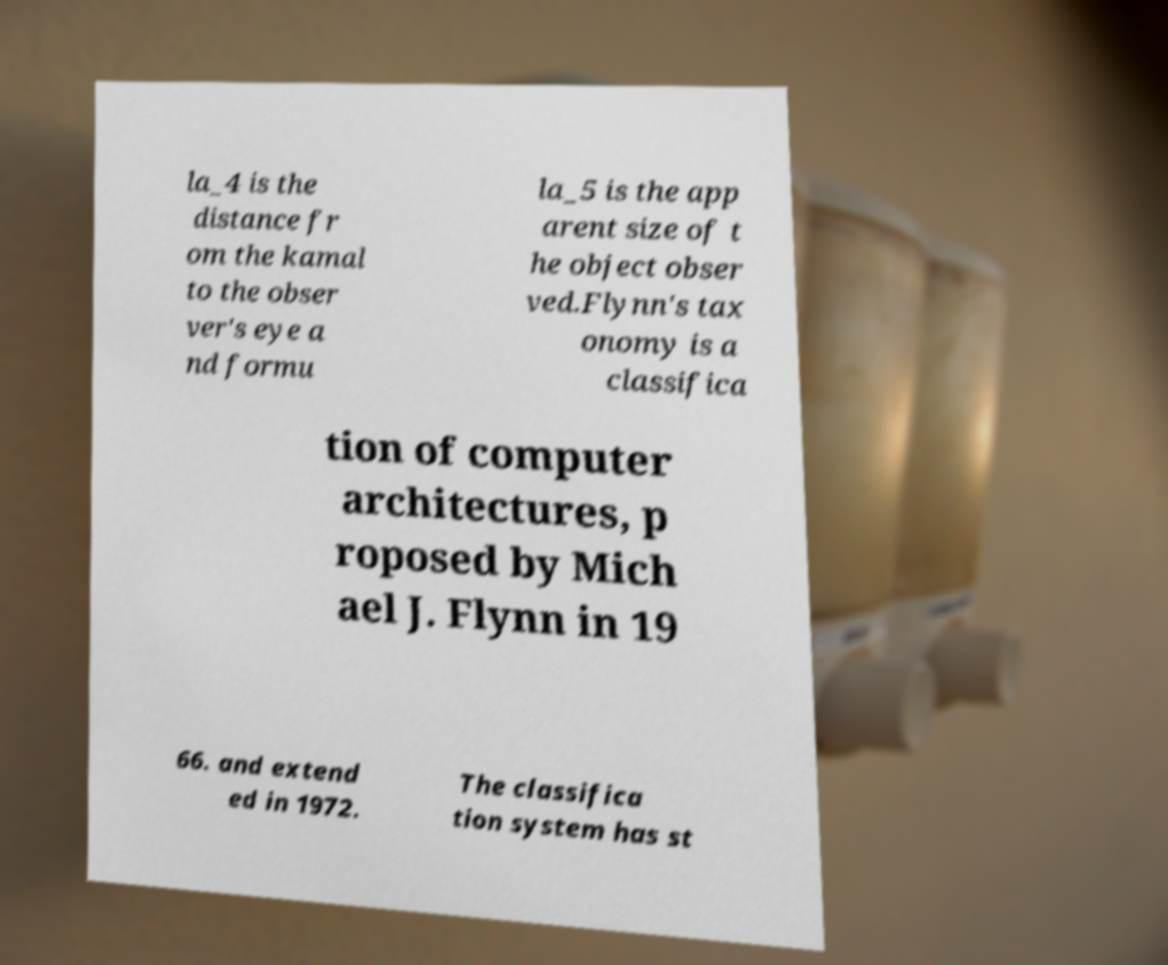What messages or text are displayed in this image? I need them in a readable, typed format. la_4 is the distance fr om the kamal to the obser ver's eye a nd formu la_5 is the app arent size of t he object obser ved.Flynn's tax onomy is a classifica tion of computer architectures, p roposed by Mich ael J. Flynn in 19 66. and extend ed in 1972. The classifica tion system has st 